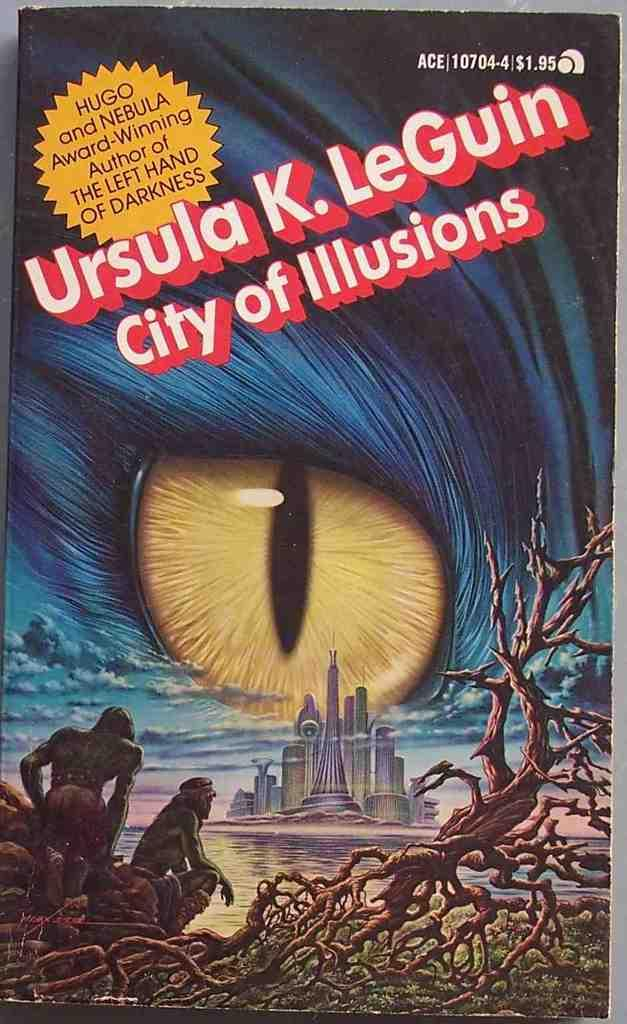<image>
Render a clear and concise summary of the photo. The author of City of Illusions, Ursula K. LeGuin, has won a Hugo and Nebula award. 